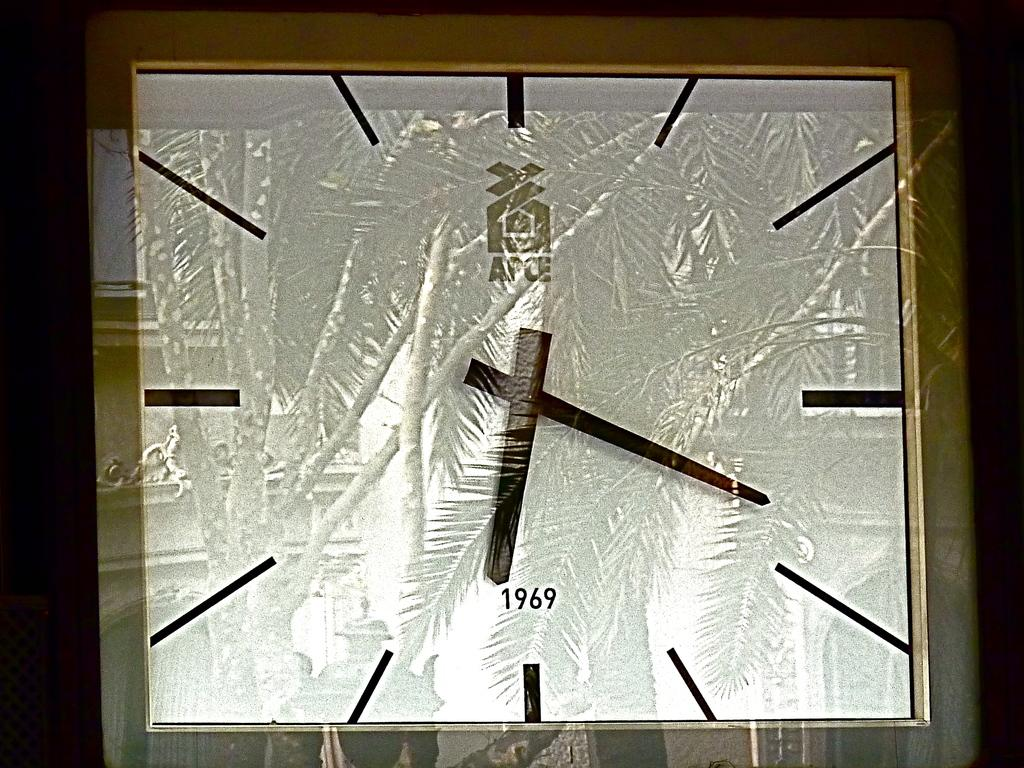<image>
Relay a brief, clear account of the picture shown. An APCE analog clock from 1969 only has dashes for the different hours. 